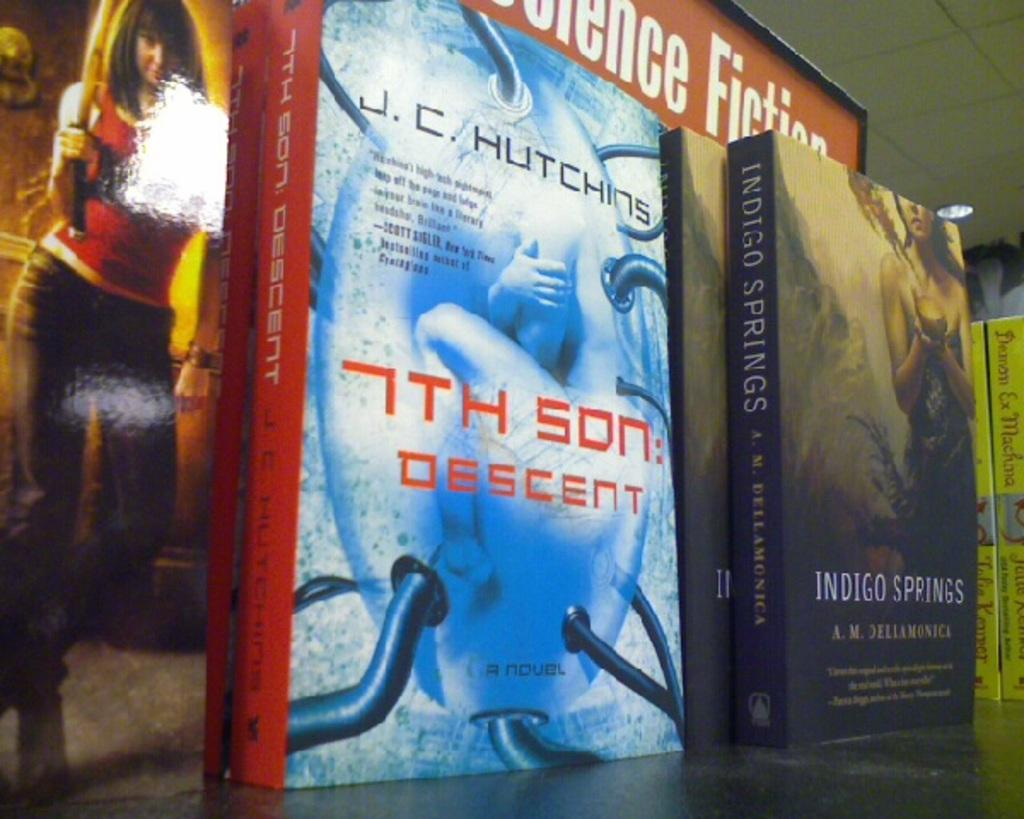<image>
Provide a brief description of the given image. a couple of books that are in the science fiction section 